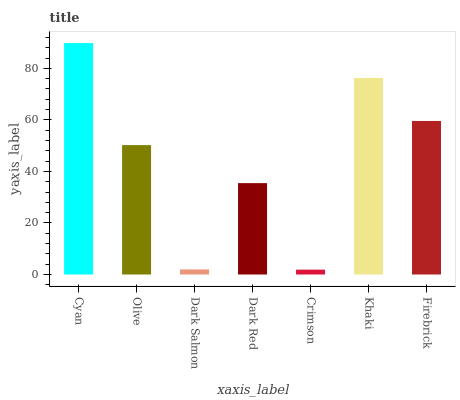Is Crimson the minimum?
Answer yes or no. Yes. Is Cyan the maximum?
Answer yes or no. Yes. Is Olive the minimum?
Answer yes or no. No. Is Olive the maximum?
Answer yes or no. No. Is Cyan greater than Olive?
Answer yes or no. Yes. Is Olive less than Cyan?
Answer yes or no. Yes. Is Olive greater than Cyan?
Answer yes or no. No. Is Cyan less than Olive?
Answer yes or no. No. Is Olive the high median?
Answer yes or no. Yes. Is Olive the low median?
Answer yes or no. Yes. Is Cyan the high median?
Answer yes or no. No. Is Dark Red the low median?
Answer yes or no. No. 